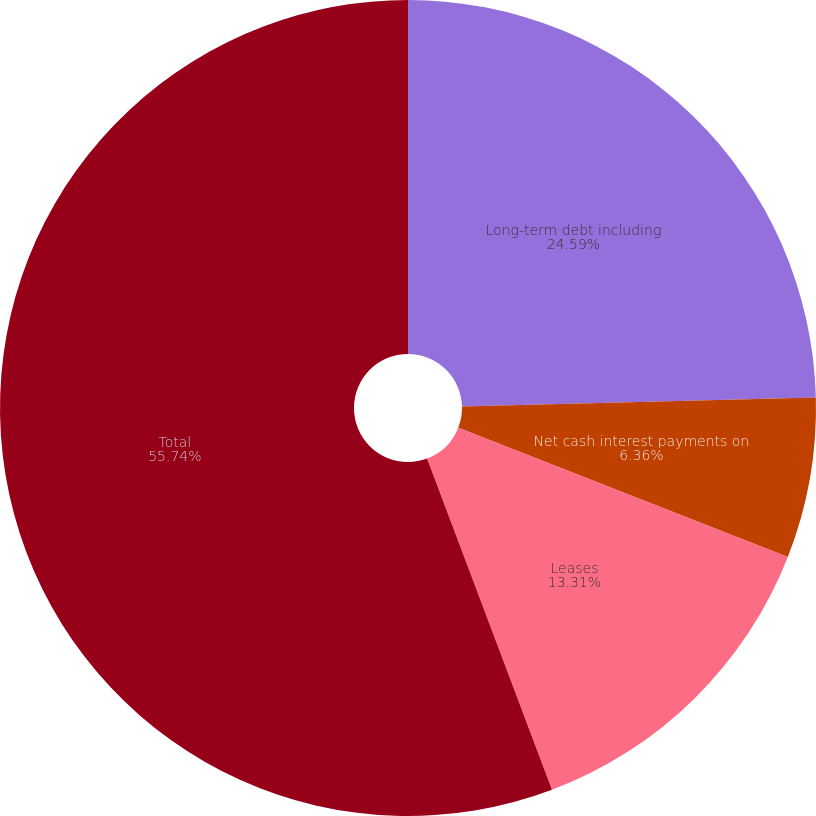Convert chart. <chart><loc_0><loc_0><loc_500><loc_500><pie_chart><fcel>Long-term debt including<fcel>Net cash interest payments on<fcel>Leases<fcel>Total<nl><fcel>24.59%<fcel>6.36%<fcel>13.31%<fcel>55.74%<nl></chart> 